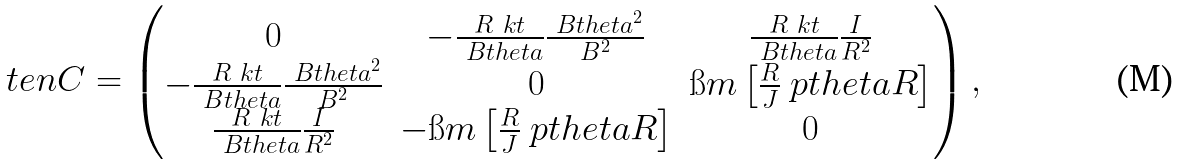<formula> <loc_0><loc_0><loc_500><loc_500>\ t e n { C } = \begin{pmatrix} 0 & - \frac { R \ k t } { \ B t h e t a } \frac { \ B t h e t a ^ { 2 } } { B ^ { 2 } } & \frac { R \ k t } { \ B t h e t a } \frac { I } { R ^ { 2 } } \\ - \frac { R \ k t } { \ B t h e t a } \frac { \ B t h e t a ^ { 2 } } { B ^ { 2 } } & 0 & \i m \left [ \frac { R } { J } \ p t h e t a R \right ] \\ \frac { R \ k t } { \ B t h e t a } \frac { I } { R ^ { 2 } } & - \i m \left [ \frac { R } { J } \ p t h e t a R \right ] & 0 \end{pmatrix} ,</formula> 